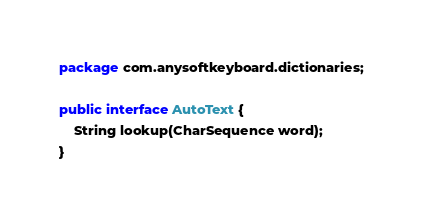Convert code to text. <code><loc_0><loc_0><loc_500><loc_500><_Java_>package com.anysoftkeyboard.dictionaries;

public interface AutoText {
    String lookup(CharSequence word);
}
</code> 